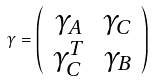<formula> <loc_0><loc_0><loc_500><loc_500>\gamma = \left ( \begin{array} { c c } \gamma _ { A } & \gamma _ { C } \\ \gamma _ { C } ^ { T } & \gamma _ { B } \end{array} \right )</formula> 